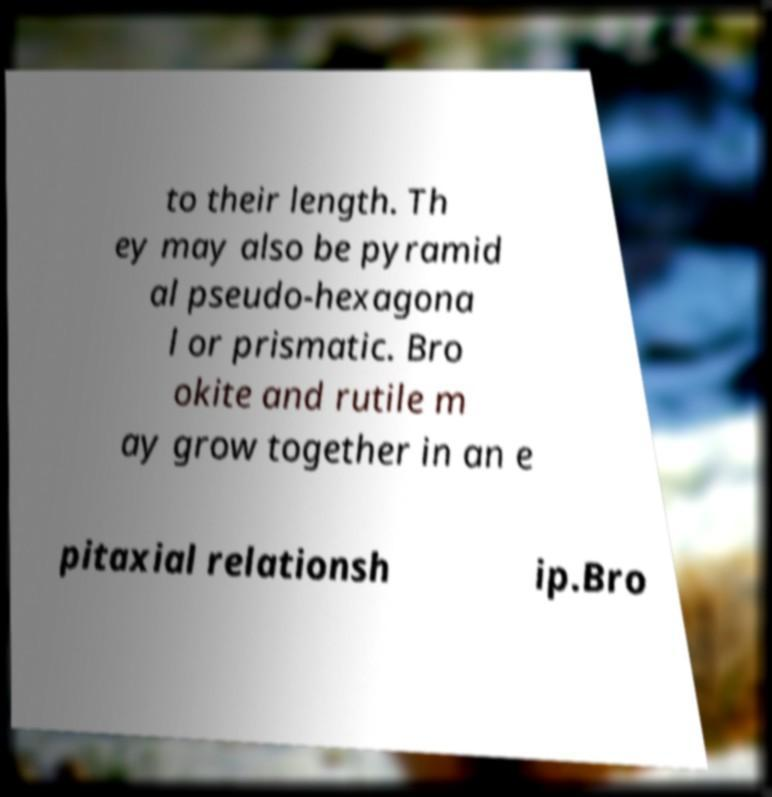For documentation purposes, I need the text within this image transcribed. Could you provide that? to their length. Th ey may also be pyramid al pseudo-hexagona l or prismatic. Bro okite and rutile m ay grow together in an e pitaxial relationsh ip.Bro 